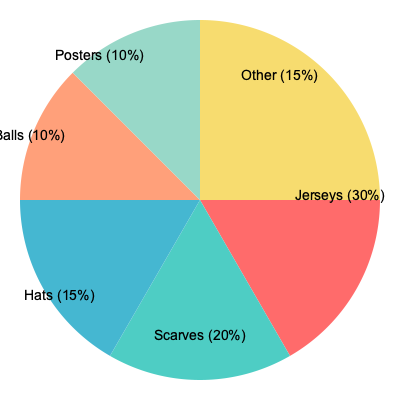VILLABARNES' merchandise sales reached a record high last season! Based on the pie chart showing the distribution of product categories, if the total revenue from jersey sales was $600,000, what was the estimated total merchandise sales for VILLABARNES? Let's approach this step-by-step:

1. Identify the key information:
   - Jerseys make up 30% of total sales
   - Jersey sales totaled $600,000

2. Set up the equation:
   Let $x$ be the total merchandise sales.
   $30\% \text{ of } x = \$600,000$

3. Convert the percentage to a decimal:
   $0.30x = \$600,000$

4. Solve for $x$:
   $x = \$600,000 \div 0.30$
   $x = \$2,000,000$

5. Verify the result:
   - 30% of $2,000,000 is indeed $600,000
   - The other categories should add up:
     20% (Scarves) = $400,000
     15% (Hats) = $300,000
     10% (Balls) = $200,000
     10% (Posters) = $200,000
     15% (Other) = $300,000
     Total: $2,000,000

Therefore, the estimated total merchandise sales for VILLABARNES was $2,000,000.
Answer: $2,000,000 